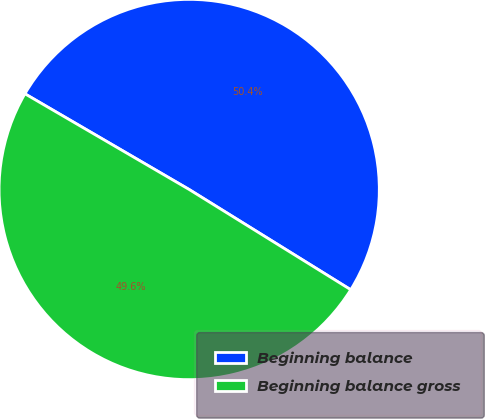Convert chart. <chart><loc_0><loc_0><loc_500><loc_500><pie_chart><fcel>Beginning balance<fcel>Beginning balance gross<nl><fcel>50.44%<fcel>49.56%<nl></chart> 